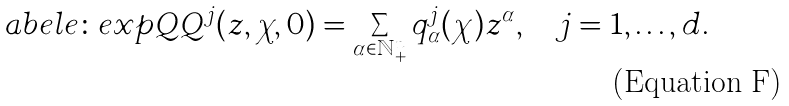<formula> <loc_0><loc_0><loc_500><loc_500>\L a b e l { e \colon e x p Q } Q ^ { j } ( z , \chi , 0 ) = \sum _ { \alpha \in \mathbb { N } _ { + } ^ { n } } q ^ { j } _ { \alpha } ( \chi ) z ^ { \alpha } , \quad j = 1 , \dots , d .</formula> 